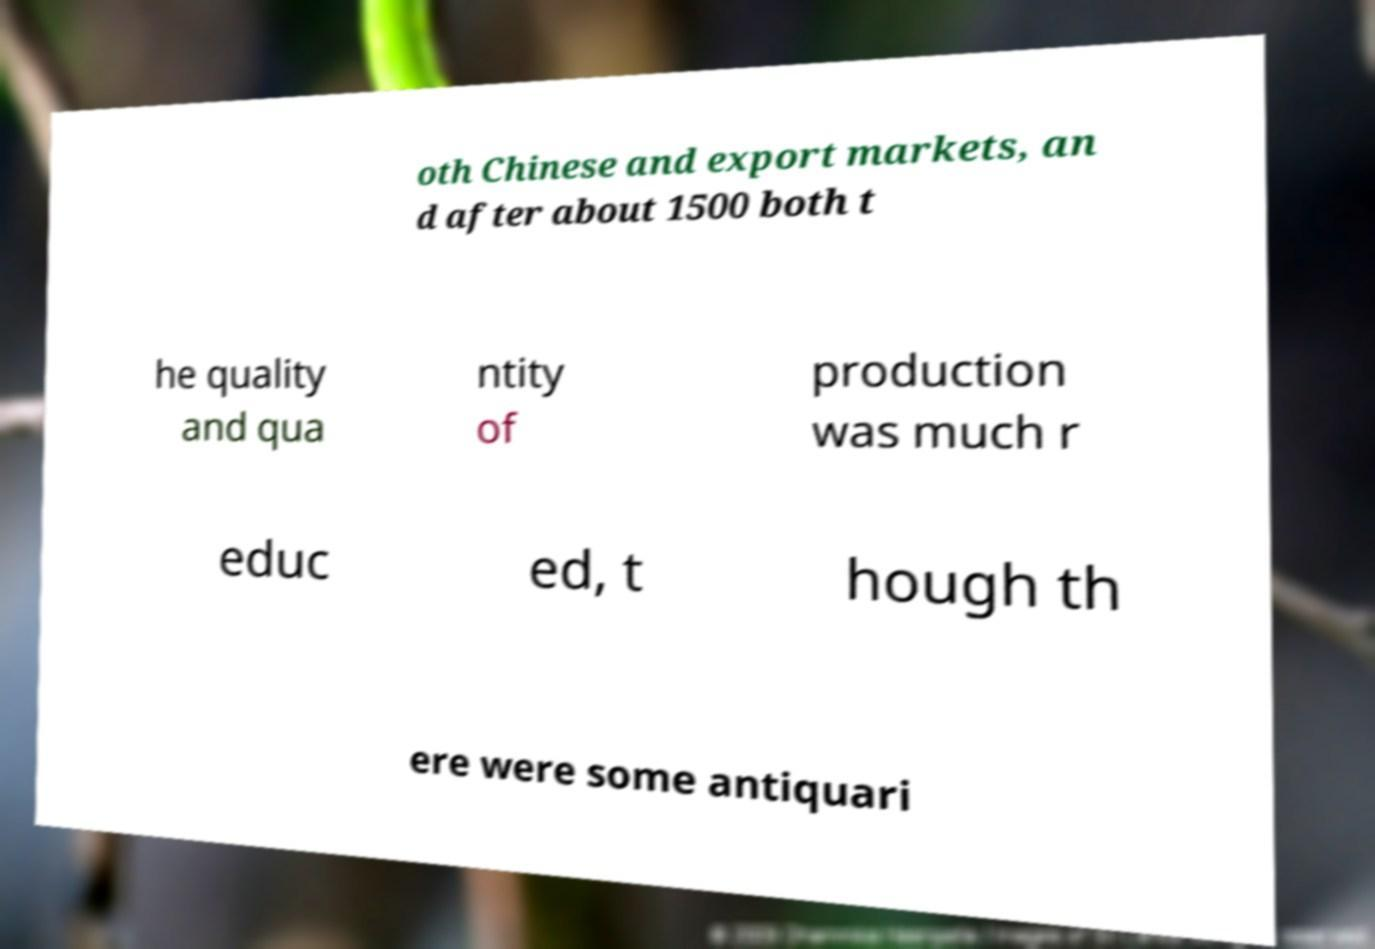Please read and relay the text visible in this image. What does it say? oth Chinese and export markets, an d after about 1500 both t he quality and qua ntity of production was much r educ ed, t hough th ere were some antiquari 